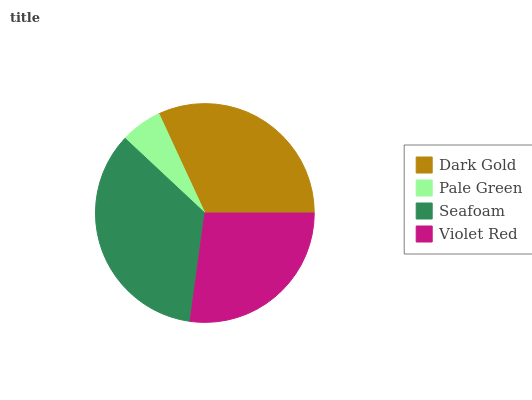Is Pale Green the minimum?
Answer yes or no. Yes. Is Seafoam the maximum?
Answer yes or no. Yes. Is Seafoam the minimum?
Answer yes or no. No. Is Pale Green the maximum?
Answer yes or no. No. Is Seafoam greater than Pale Green?
Answer yes or no. Yes. Is Pale Green less than Seafoam?
Answer yes or no. Yes. Is Pale Green greater than Seafoam?
Answer yes or no. No. Is Seafoam less than Pale Green?
Answer yes or no. No. Is Dark Gold the high median?
Answer yes or no. Yes. Is Violet Red the low median?
Answer yes or no. Yes. Is Violet Red the high median?
Answer yes or no. No. Is Seafoam the low median?
Answer yes or no. No. 